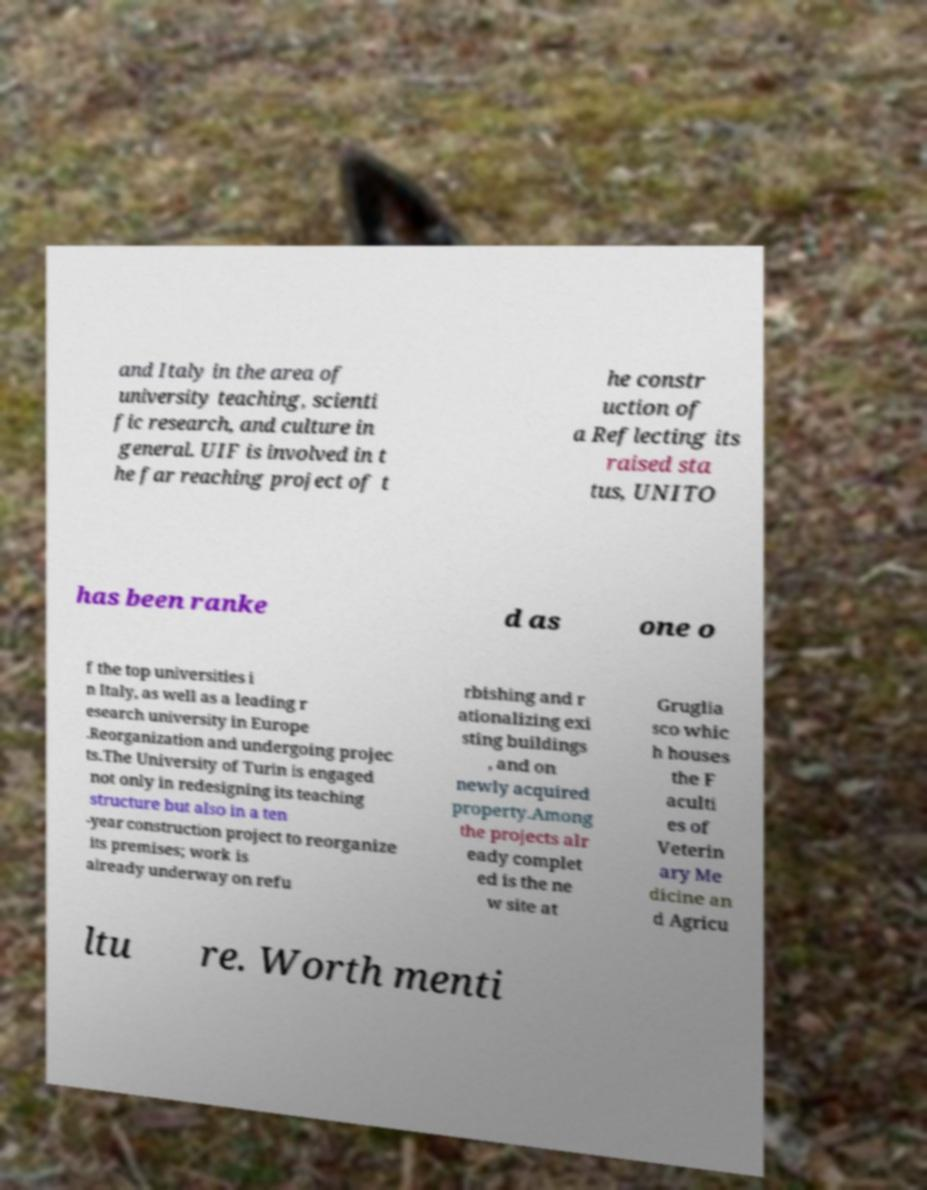Please read and relay the text visible in this image. What does it say? and Italy in the area of university teaching, scienti fic research, and culture in general. UIF is involved in t he far reaching project of t he constr uction of a Reflecting its raised sta tus, UNITO has been ranke d as one o f the top universities i n Italy, as well as a leading r esearch university in Europe .Reorganization and undergoing projec ts.The University of Turin is engaged not only in redesigning its teaching structure but also in a ten -year construction project to reorganize its premises; work is already underway on refu rbishing and r ationalizing exi sting buildings , and on newly acquired property.Among the projects alr eady complet ed is the ne w site at Gruglia sco whic h houses the F aculti es of Veterin ary Me dicine an d Agricu ltu re. Worth menti 